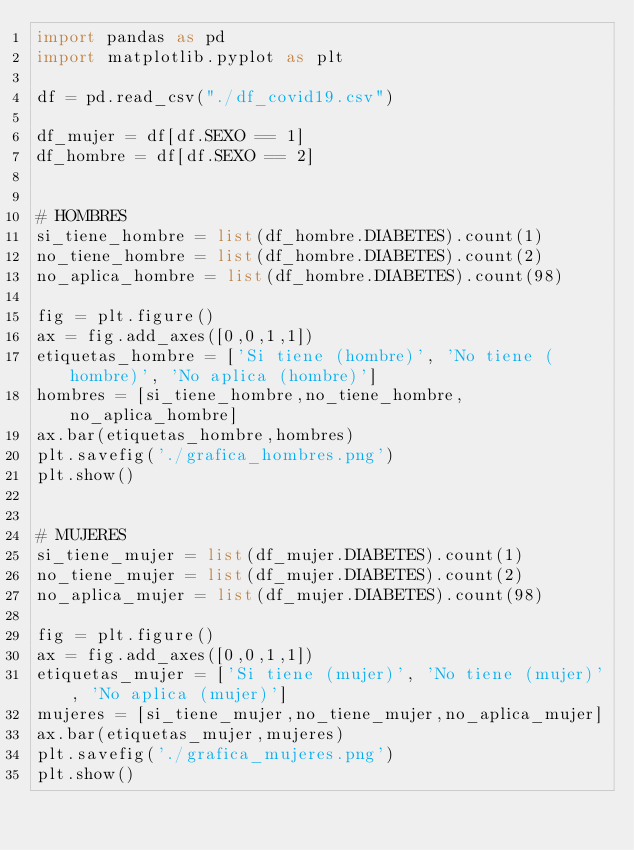<code> <loc_0><loc_0><loc_500><loc_500><_Python_>import pandas as pd
import matplotlib.pyplot as plt

df = pd.read_csv("./df_covid19.csv")

df_mujer = df[df.SEXO == 1]
df_hombre = df[df.SEXO == 2]


# HOMBRES
si_tiene_hombre = list(df_hombre.DIABETES).count(1)
no_tiene_hombre = list(df_hombre.DIABETES).count(2)
no_aplica_hombre = list(df_hombre.DIABETES).count(98)

fig = plt.figure()
ax = fig.add_axes([0,0,1,1])
etiquetas_hombre = ['Si tiene (hombre)', 'No tiene (hombre)', 'No aplica (hombre)']
hombres = [si_tiene_hombre,no_tiene_hombre,no_aplica_hombre]
ax.bar(etiquetas_hombre,hombres)
plt.savefig('./grafica_hombres.png')
plt.show()


# MUJERES
si_tiene_mujer = list(df_mujer.DIABETES).count(1)
no_tiene_mujer = list(df_mujer.DIABETES).count(2)
no_aplica_mujer = list(df_mujer.DIABETES).count(98)

fig = plt.figure()
ax = fig.add_axes([0,0,1,1])
etiquetas_mujer = ['Si tiene (mujer)', 'No tiene (mujer)', 'No aplica (mujer)']
mujeres = [si_tiene_mujer,no_tiene_mujer,no_aplica_mujer]
ax.bar(etiquetas_mujer,mujeres)
plt.savefig('./grafica_mujeres.png')
plt.show()
</code> 